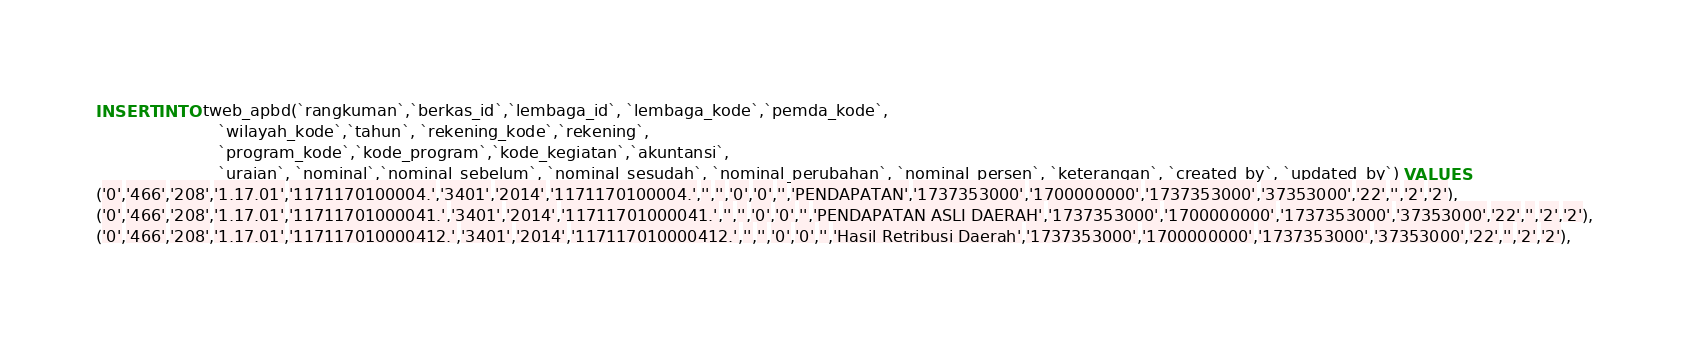<code> <loc_0><loc_0><loc_500><loc_500><_SQL_>INSERT INTO tweb_apbd(`rangkuman`,`berkas_id`,`lembaga_id`, `lembaga_kode`,`pemda_kode`, 
						`wilayah_kode`,`tahun`, `rekening_kode`,`rekening`, 
						`program_kode`,`kode_program`,`kode_kegiatan`,`akuntansi`,
						`uraian`, `nominal`,`nominal_sebelum`, `nominal_sesudah`, `nominal_perubahan`, `nominal_persen`, `keterangan`, `created_by`, `updated_by`) VALUES 
('0','466','208','1.17.01','1171170100004.','3401','2014','1171170100004.','','','0','0','','PENDAPATAN','1737353000','1700000000','1737353000','37353000','22','','2','2'),
('0','466','208','1.17.01','11711701000041.','3401','2014','11711701000041.','','','0','0','','PENDAPATAN ASLI DAERAH','1737353000','1700000000','1737353000','37353000','22','','2','2'),
('0','466','208','1.17.01','117117010000412.','3401','2014','117117010000412.','','','0','0','','Hasil Retribusi Daerah','1737353000','1700000000','1737353000','37353000','22','','2','2'),</code> 